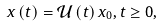<formula> <loc_0><loc_0><loc_500><loc_500>{ x } \left ( t \right ) = \mathcal { U } \left ( t \right ) x _ { 0 } , t \geq 0 ,</formula> 